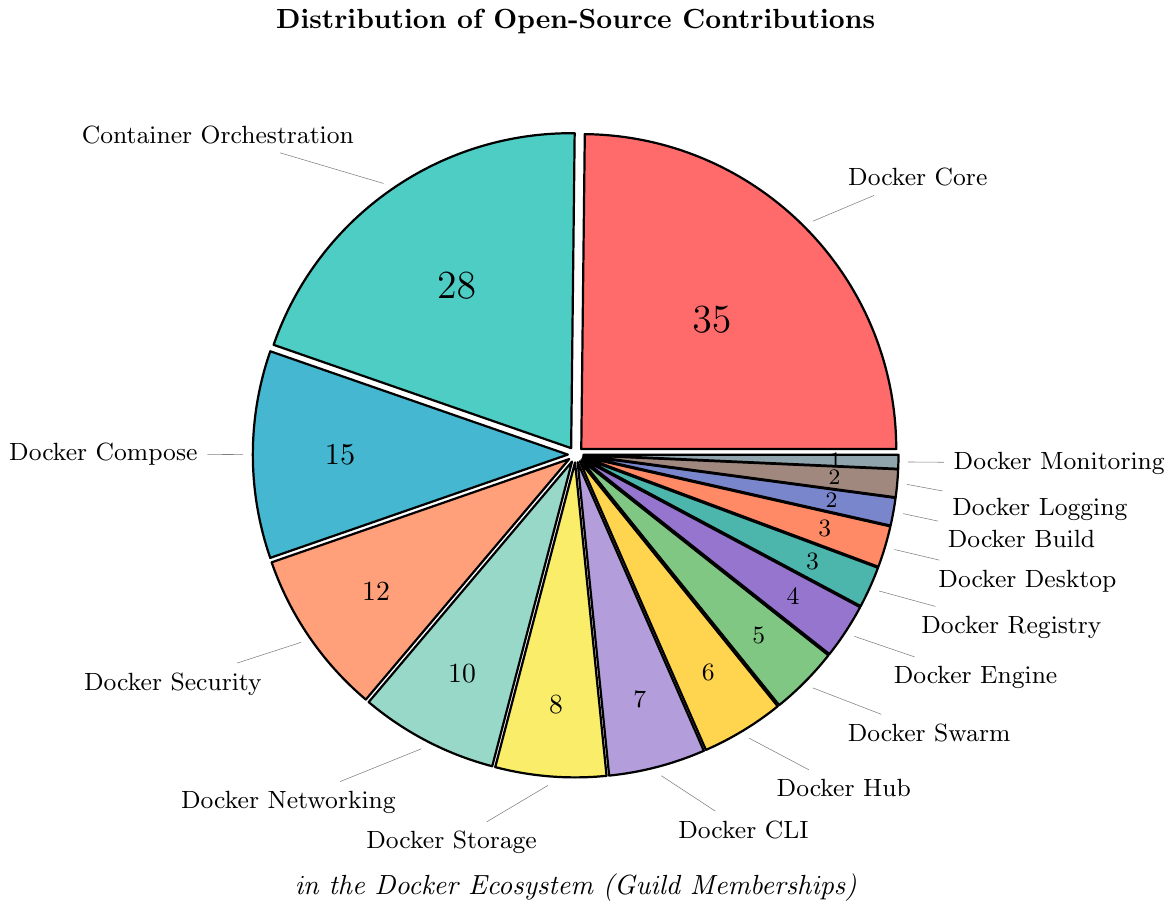What's the most contributed guild in the Docker ecosystem? By examining the pie chart, we can see that the Docker Core Guild has the largest slice, indicating the highest number of contributions.
Answer: Docker Core Guild How many more contributions does the Docker Core Guild have compared to the Docker Compose Guild? The Docker Core Guild has 35 contributions and the Docker Compose Guild has 15. Subtracting the two gives us 35 - 15 = 20.
Answer: 20 Which guild has the smallest number of contributions? The pie chart shows that the Docker Monitoring Guild has the smallest slice, representing just 1 contribution.
Answer: Docker Monitoring Guild What’s the total number of contributions by the Docker Security, Docker CLI, and Docker Hub Guilds combined? The contributions are 12 for Docker Security, 7 for Docker CLI, and 6 for Docker Hub. Summing them up gives us 12 + 7 + 6 = 25.
Answer: 25 What’s the difference in contributions between the Docker Container Orchestration Guild and the sum of Docker Storage and Docker Networking Guilds? The Container Orchestration Guild has 28 contributions. Docker Storage has 8 and Docker Networking has 10. Summing Docker Storage and Docker Networking gives 8 + 10 = 18. The difference is 28 - 18 = 10.
Answer: 10 Which guilds have contributions less than or equal to 5? By scanning the pie chart, we find that Docker Swarm (5), Docker Engine (4), Docker Registry (3), Docker Desktop (3), Docker Build (2), Docker Logging (2), and Docker Monitoring (1) all have contributions less than or equal to 5.
Answer: Docker Swarm Guild, Docker Engine Guild, Docker Registry Guild, Docker Desktop Guild, Docker Build Guild, Docker Logging Guild, Docker Monitoring Guild Compare the total contributions of Docker Storage, Docker CLI, and Docker Hub with those of Docker Core Guild. Which is higher? Docker Storage has 8 contributions, Docker CLI has 7, and Docker Hub has 6. Summing them up gives 8 + 7 + 6 = 21. Docker Core Guild has 35 contributions. Thus, Docker Core Guild has higher contributions (35 vs 21).
Answer: Docker Core Guild What percentage of the total contributions does the Docker Security Guild represent? The Docker Security Guild has 12 contributions, and the total contributions sum up to 141. Calculating the percentage: (12 / 141) * 100 ≈ 8.51%.
Answer: ~8.51% Which guilds together cover more than 50% of the total contributions? Calculating the percentages: Docker Core (35/141) ≈ 24.82%, Container Orchestration (28/141) ≈ 19.86%, and Docker Compose (15/141) ≈ 10.64%. Summing these percentages: 24.82% + 19.86% + 10.64% = 55.32%, which is more than 50%. These three guilds together cover more than 50%.
Answer: Docker Core Guild, Container Orchestration Guild, Docker Compose Guild What fraction of the total contributions is made by guilds with less than 10 contributions each? The guilds with less than 10 contributions: Docker CLI (7), Docker Hub (6), Docker Swarm (5), Docker Engine (4), Docker Registry (3), Docker Desktop (3), Docker Build (2), Docker Logging (2), and Docker Monitoring (1). Summing these gives 7 + 6 + 5 + 4 + 3 + 3 + 2 + 2 + 1 = 33. The total contributions are 141. Therefore, the fraction is 33 / 141 ≈ 0.234.
Answer: ~0.234 